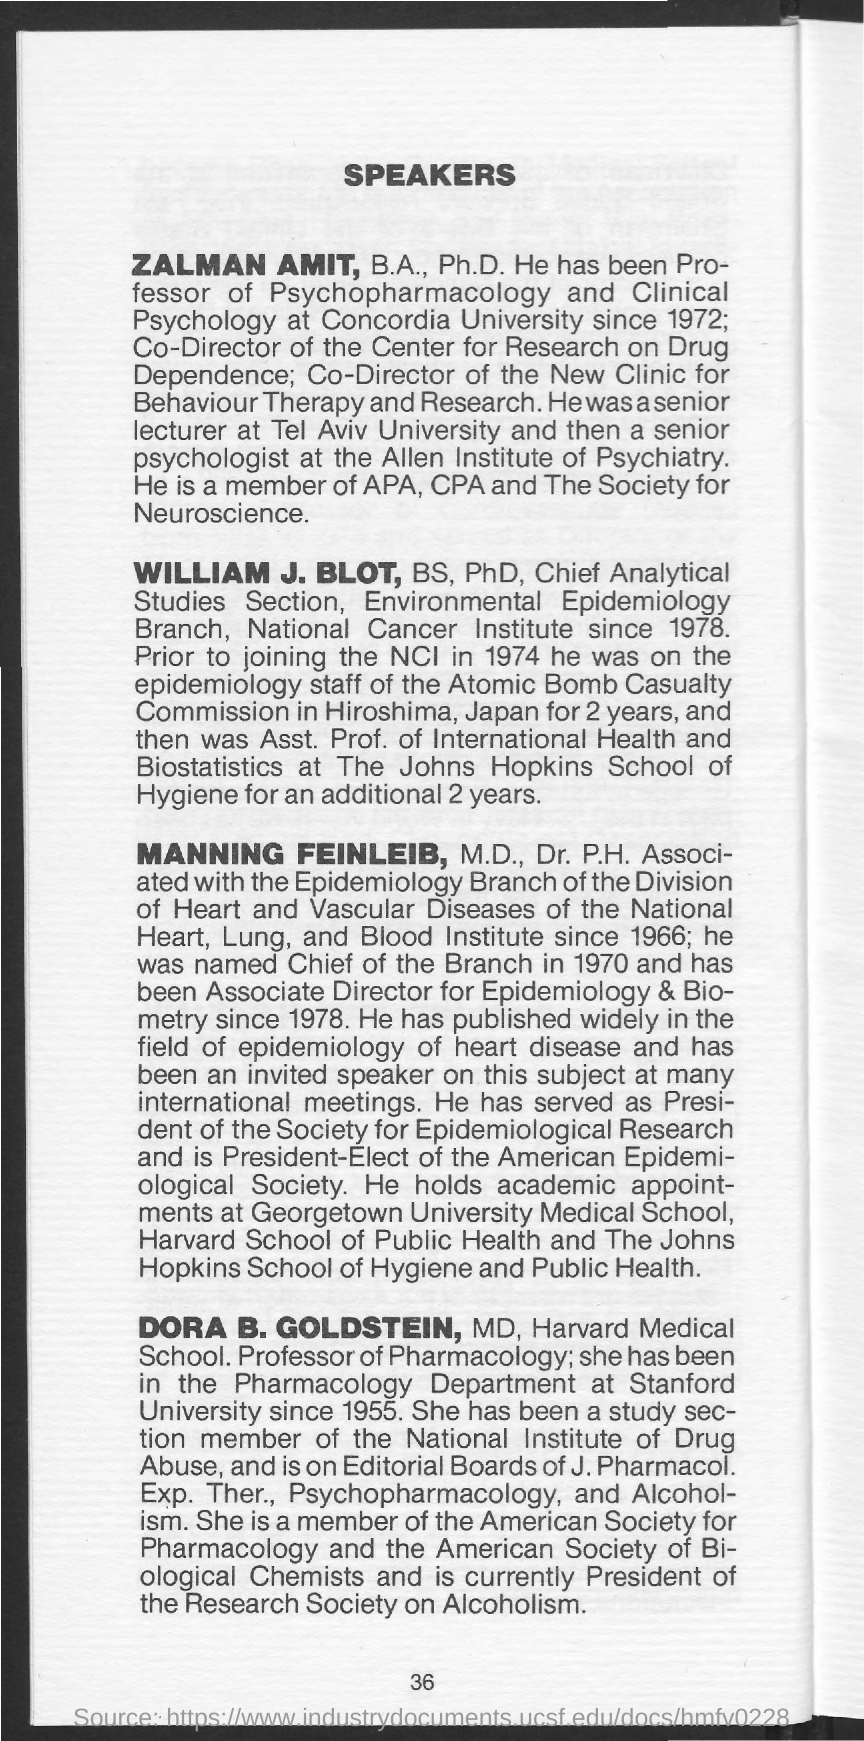Point out several critical features in this image. The page number is 36, as declared. 